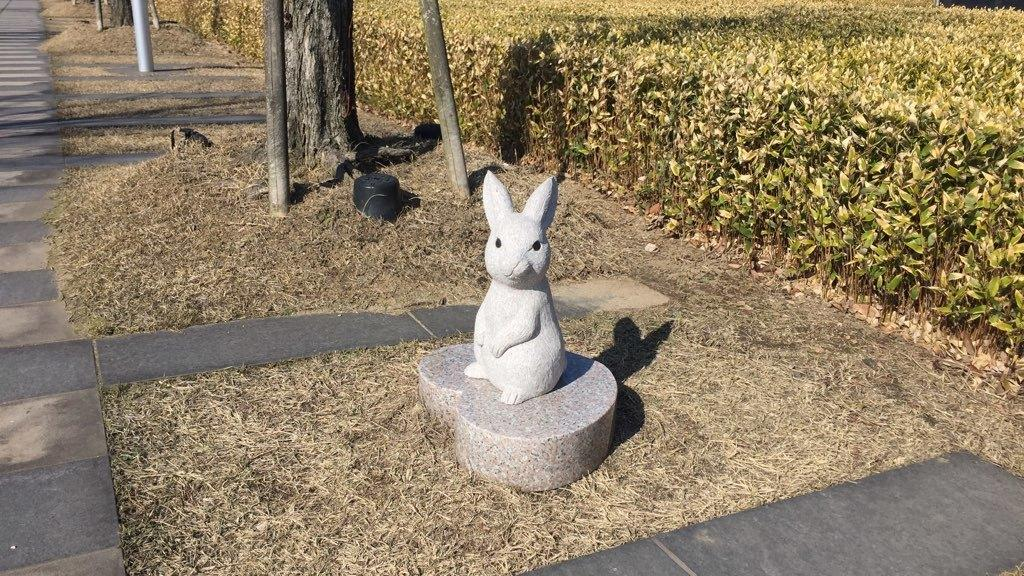What is the main subject in the middle of the image? There is a statue of a rabbit in the middle of the image. What can be seen on the top left side of the image? There is a trunk of a tree on the top left side of the image. What type of landscape is visible on the right side of the image? There is an agriculture field on the right side of the image. How many beds are visible in the image? There are no beds present in the image. What type of finger can be seen interacting with the statue in the image? There is no finger present in the image; it only features a statue of a rabbit, a tree trunk, and an agriculture field. 